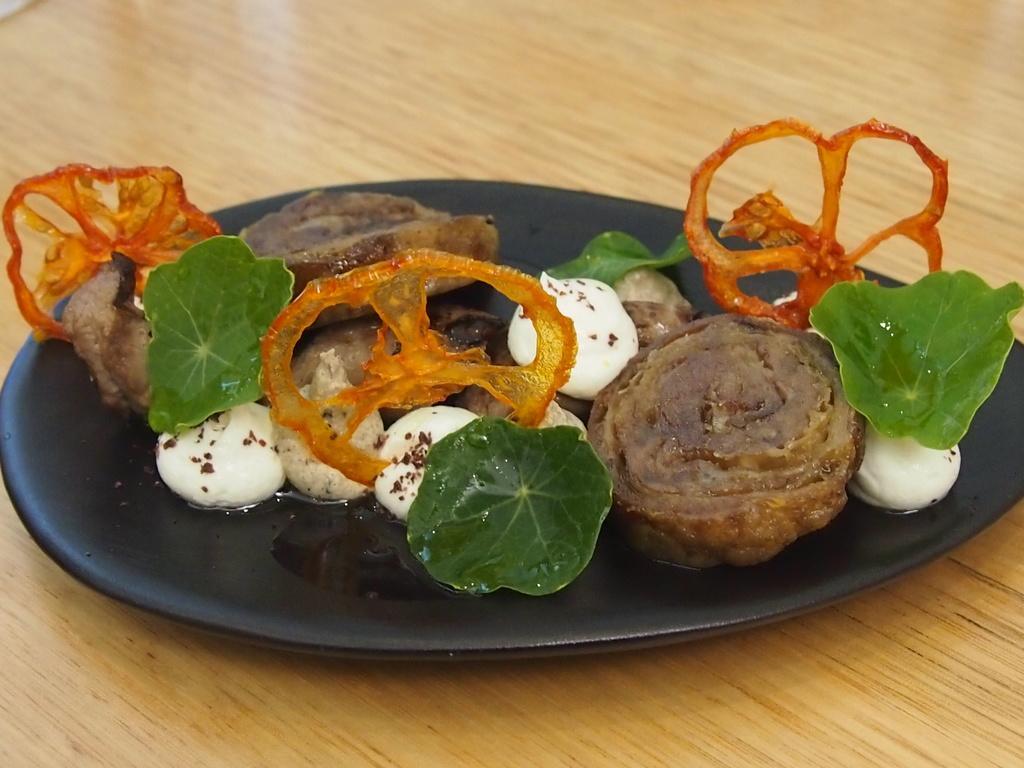Can you describe this image briefly? In the center of the image there are foods items in plate on the table. 